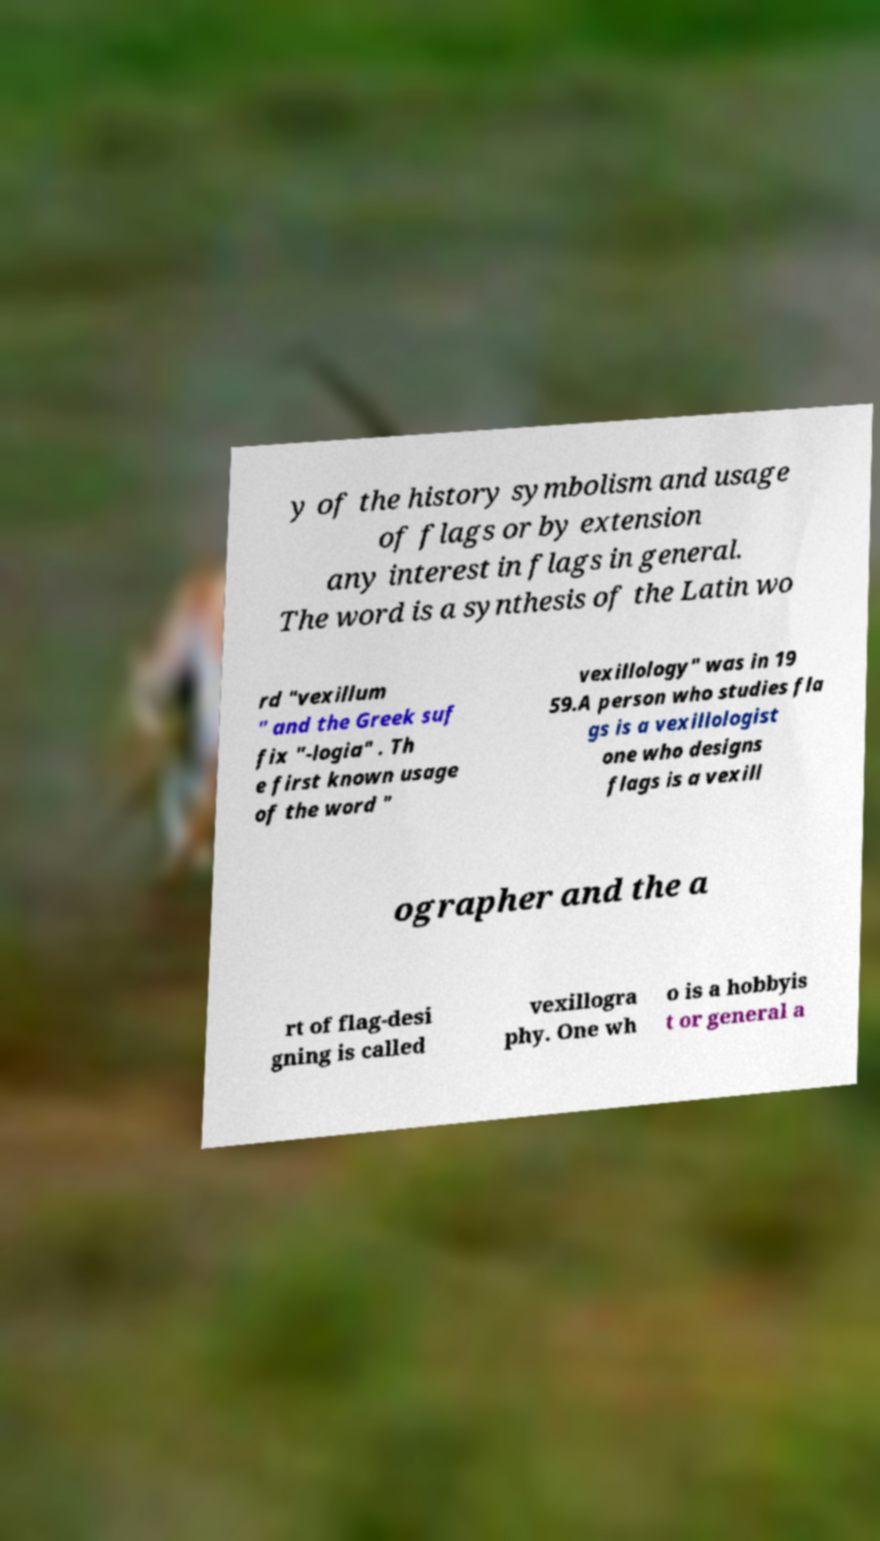There's text embedded in this image that I need extracted. Can you transcribe it verbatim? y of the history symbolism and usage of flags or by extension any interest in flags in general. The word is a synthesis of the Latin wo rd "vexillum " and the Greek suf fix "-logia" . Th e first known usage of the word " vexillology" was in 19 59.A person who studies fla gs is a vexillologist one who designs flags is a vexill ographer and the a rt of flag-desi gning is called vexillogra phy. One wh o is a hobbyis t or general a 